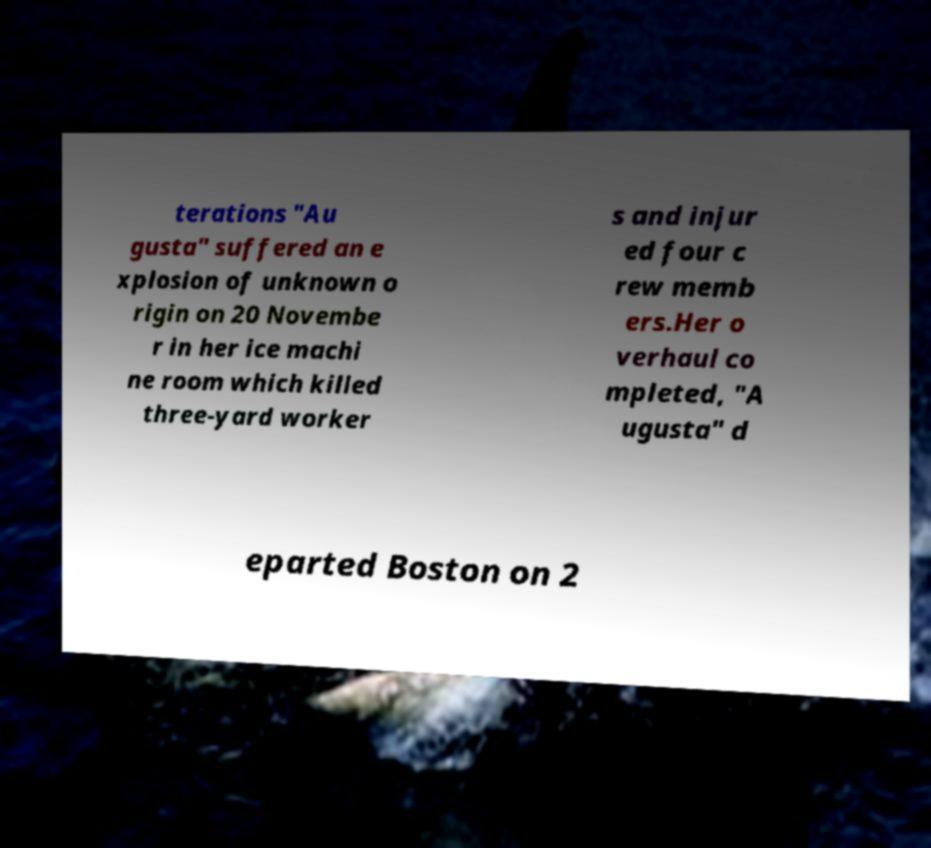Could you assist in decoding the text presented in this image and type it out clearly? terations "Au gusta" suffered an e xplosion of unknown o rigin on 20 Novembe r in her ice machi ne room which killed three-yard worker s and injur ed four c rew memb ers.Her o verhaul co mpleted, "A ugusta" d eparted Boston on 2 